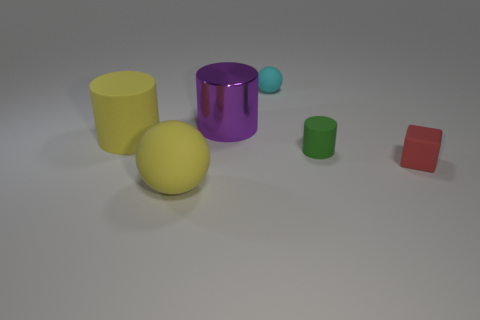Subtract all yellow cylinders. How many cylinders are left? 2 Subtract all yellow cylinders. How many cylinders are left? 2 Add 1 tiny gray shiny cylinders. How many objects exist? 7 Subtract all blocks. How many objects are left? 5 Subtract 1 cylinders. How many cylinders are left? 2 Add 3 green matte things. How many green matte things exist? 4 Subtract 0 blue cylinders. How many objects are left? 6 Subtract all gray cylinders. Subtract all purple spheres. How many cylinders are left? 3 Subtract all yellow cylinders. How many yellow spheres are left? 1 Subtract all red metallic cylinders. Subtract all red rubber blocks. How many objects are left? 5 